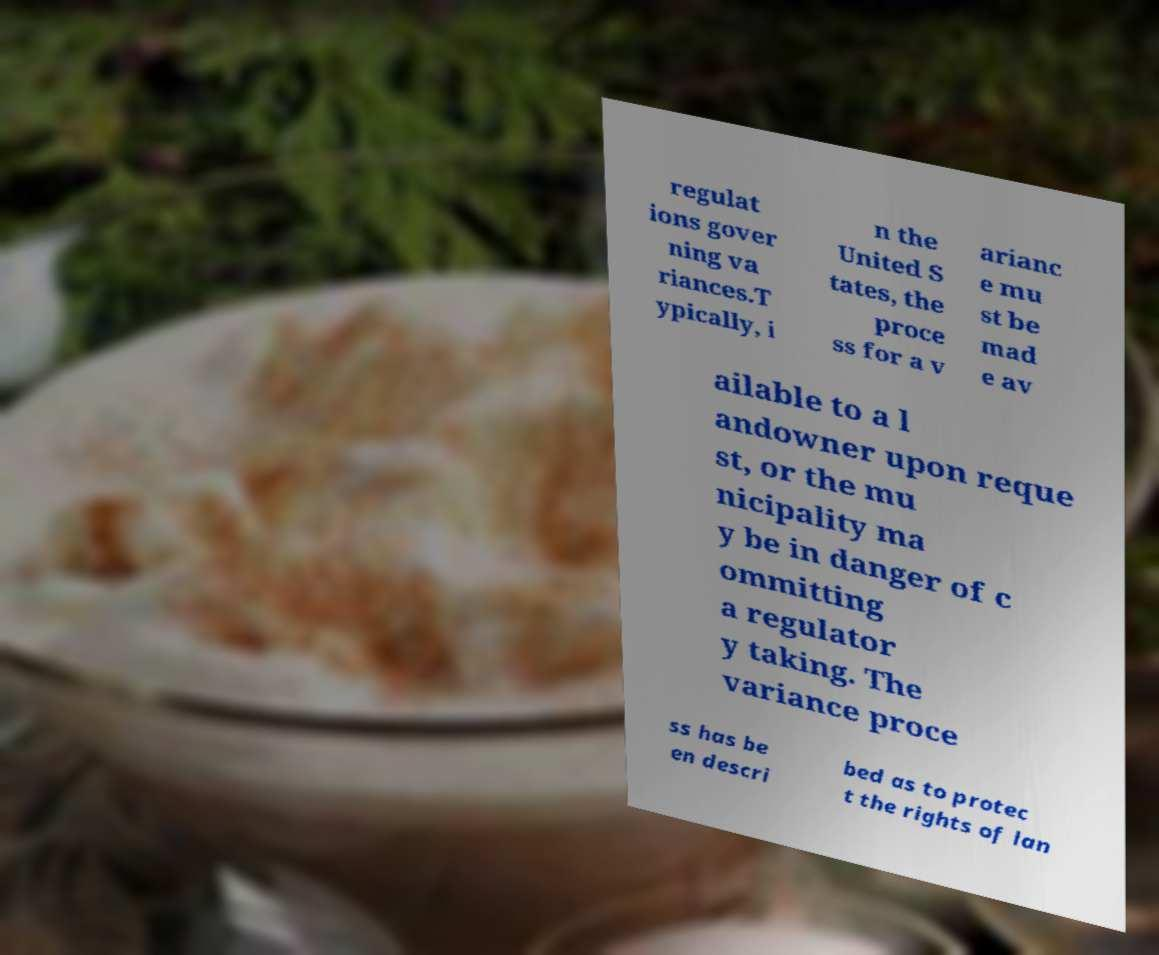Can you read and provide the text displayed in the image?This photo seems to have some interesting text. Can you extract and type it out for me? regulat ions gover ning va riances.T ypically, i n the United S tates, the proce ss for a v arianc e mu st be mad e av ailable to a l andowner upon reque st, or the mu nicipality ma y be in danger of c ommitting a regulator y taking. The variance proce ss has be en descri bed as to protec t the rights of lan 